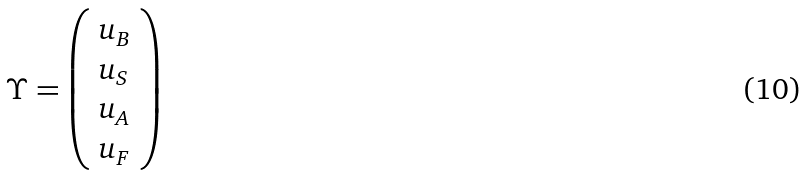<formula> <loc_0><loc_0><loc_500><loc_500>\Upsilon = \left ( \begin{array} { l } { { u _ { B } } } \\ { { u _ { S } } } \\ { { u _ { A } } } \\ { { u _ { F } } } \end{array} \right )</formula> 